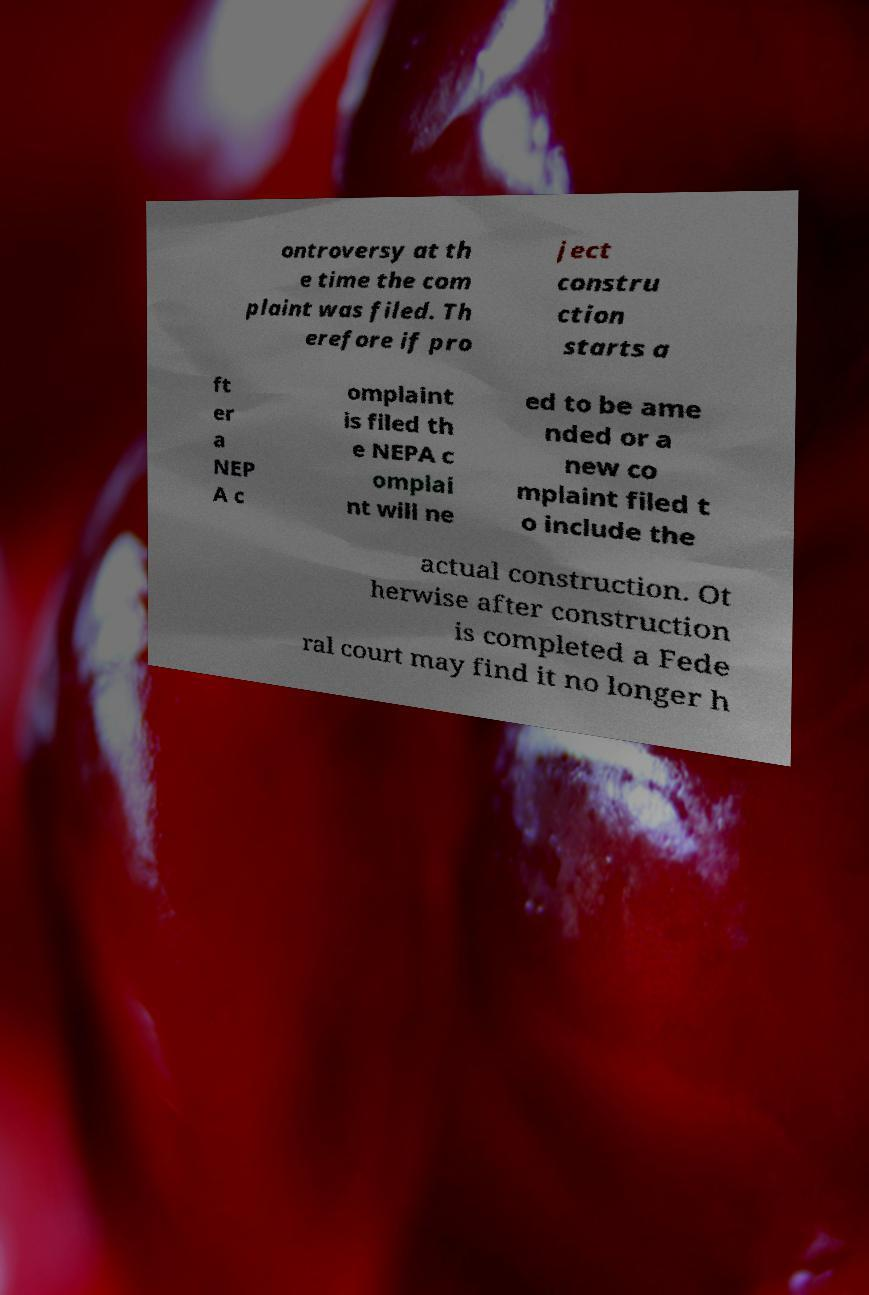For documentation purposes, I need the text within this image transcribed. Could you provide that? ontroversy at th e time the com plaint was filed. Th erefore if pro ject constru ction starts a ft er a NEP A c omplaint is filed th e NEPA c omplai nt will ne ed to be ame nded or a new co mplaint filed t o include the actual construction. Ot herwise after construction is completed a Fede ral court may find it no longer h 